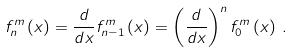Convert formula to latex. <formula><loc_0><loc_0><loc_500><loc_500>f _ { n } ^ { m } \left ( x \right ) = \frac { d } { d x } f _ { n - 1 } ^ { m } \left ( x \right ) = \left ( \frac { d } { d x } \right ) ^ { n } f _ { 0 } ^ { m } \left ( x \right ) \, .</formula> 